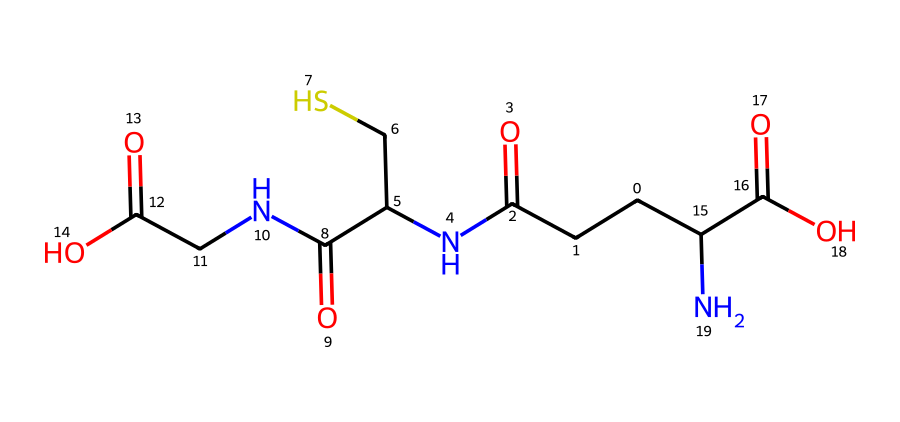What is the molecular formula of glutathione? The molecular formula can be derived from counting the number of each type of atom represented in the chemical structure. In this case, examining the structure indicates that there are carbon, hydrogen, oxygen, nitrogen, and sulfur atoms present, leading to the formula C10H17N3O6S.
Answer: C10H17N3O6S How many carbon atoms are in glutathione? By analyzing the structure represented in the SMILES, we can count the carbon atoms; there are 10 carbon atoms indicated in the formula derived from the structure.
Answer: 10 What functional groups are present in glutathione? Looking at the structure, the presence of amine (–NH), carboxylic acid (–COOH), and thiol (–SH) groups can be identified. These groups are characteristic of glutathione's reactivity.
Answer: amine, carboxylic acid, thiol Which element in glutathione serves a crucial role in antioxidant activity? The sulfur atom is crucial for the antioxidant activity, as it is involved in the redox reactions that allow glutathione to neutralize free radicals. The thiol group is particularly important for this function.
Answer: sulfur What is the significance of the carboxyl groups in glutathione? The carboxyl groups in glutathione can ionize and participate in the buffering of pH levels in the cell, which is important for maintaining cellular environment stability.
Answer: pH buffering How many nitrogen atoms are found in glutathione? Counting the nitrogen atoms in the structure indicates that there are three nitrogen atoms present, which can be seen in the amine groups attached to the molecule.
Answer: 3 What role does glutathione play in cellular health? Glutathione acts as a protector against oxidative stress by neutralizing harmful free radicals, contributing to cellular health and preventing damage.
Answer: antioxidant 